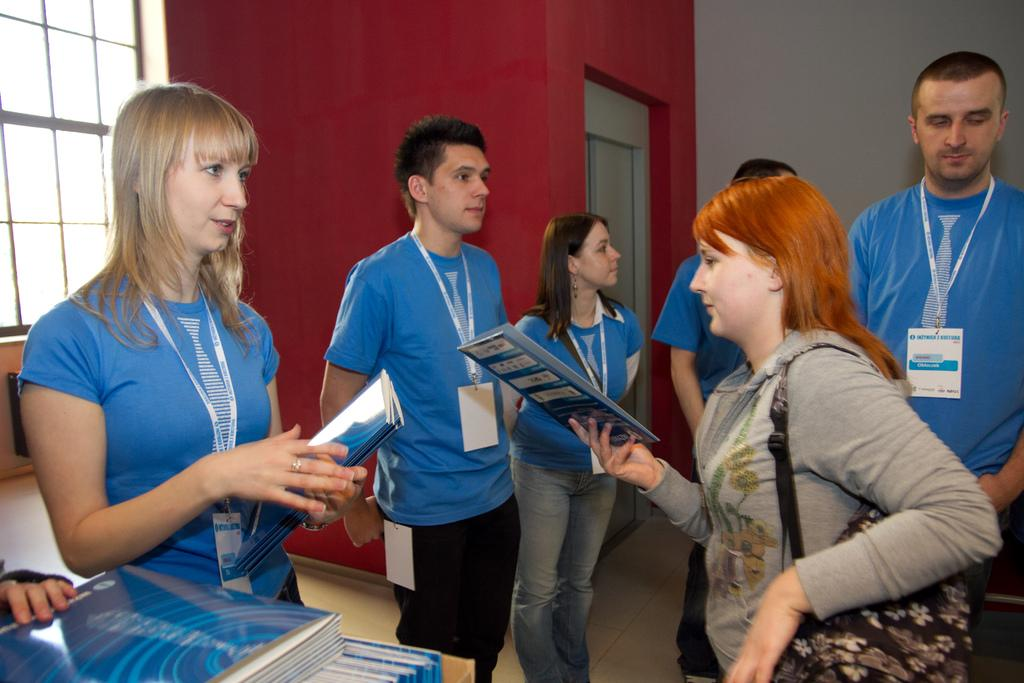How many people are in the image? There is a group of people standing in the image. What are two of the people holding? Two persons are holding books. Where are the books located in the image? There are books on an object (possibly a table or shelf) in the image. What can be seen in the background of the image? There is a wall and a window in the background of the image. What type of throne is visible in the image? There is no throne present in the image. What color is the yarn being used by the person in the image? There is no yarn or person using yarn present in the image. 